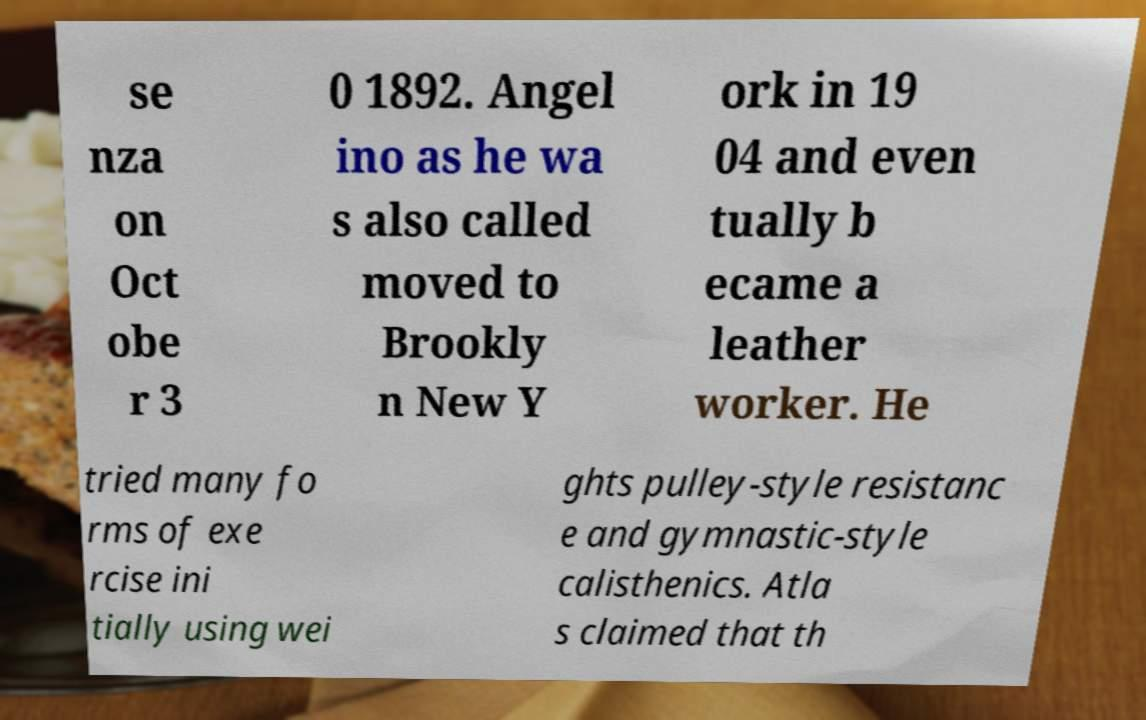Please read and relay the text visible in this image. What does it say? se nza on Oct obe r 3 0 1892. Angel ino as he wa s also called moved to Brookly n New Y ork in 19 04 and even tually b ecame a leather worker. He tried many fo rms of exe rcise ini tially using wei ghts pulley-style resistanc e and gymnastic-style calisthenics. Atla s claimed that th 